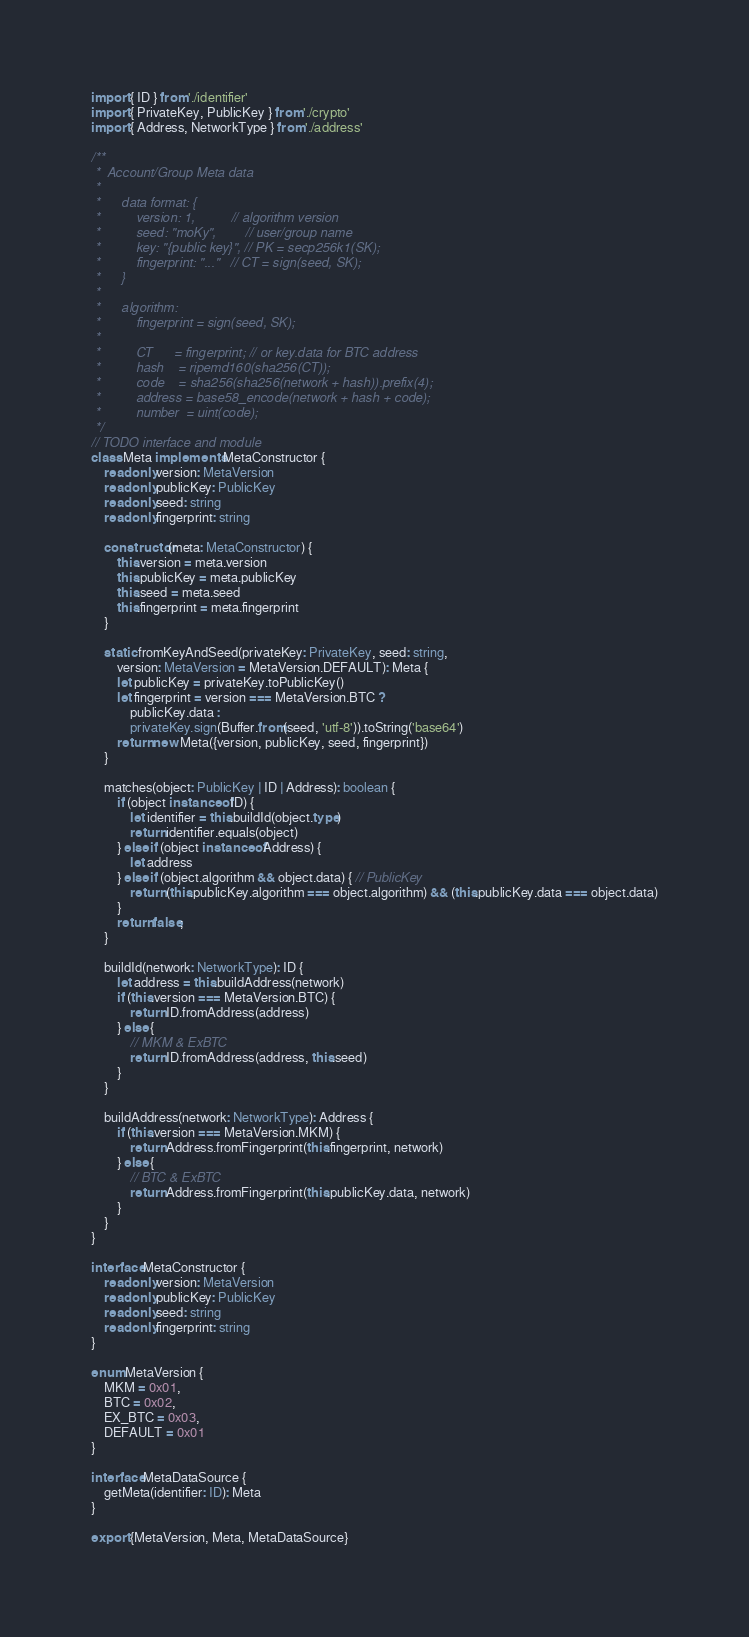<code> <loc_0><loc_0><loc_500><loc_500><_TypeScript_>import { ID } from './identifier'
import { PrivateKey, PublicKey } from './crypto'
import { Address, NetworkType } from './address'

/**
 *  Account/Group Meta data
 *
 *      data format: {
 *          version: 1,          // algorithm version
 *          seed: "moKy",        // user/group name
 *          key: "{public key}", // PK = secp256k1(SK);
 *          fingerprint: "..."   // CT = sign(seed, SK);
 *      }
 *
 *      algorithm:
 *          fingerprint = sign(seed, SK);
 *
 *          CT      = fingerprint; // or key.data for BTC address
 *          hash    = ripemd160(sha256(CT));
 *          code    = sha256(sha256(network + hash)).prefix(4);
 *          address = base58_encode(network + hash + code);
 *          number  = uint(code);
 */
// TODO interface and module
class Meta implements MetaConstructor {
    readonly version: MetaVersion
    readonly publicKey: PublicKey
    readonly seed: string
    readonly fingerprint: string

    constructor(meta: MetaConstructor) {
        this.version = meta.version
        this.publicKey = meta.publicKey
        this.seed = meta.seed
        this.fingerprint = meta.fingerprint
    }

    static fromKeyAndSeed(privateKey: PrivateKey, seed: string,
        version: MetaVersion = MetaVersion.DEFAULT): Meta {
        let publicKey = privateKey.toPublicKey()
        let fingerprint = version === MetaVersion.BTC ?
            publicKey.data :
            privateKey.sign(Buffer.from(seed, 'utf-8')).toString('base64')
        return new Meta({version, publicKey, seed, fingerprint})
    }
    
    matches(object: PublicKey | ID | Address): boolean {
        if (object instanceof ID) {
            let identifier = this.buildId(object.type)
            return identifier.equals(object)
        } else if (object instanceof Address) {
            let address
        } else if (object.algorithm && object.data) { // PublicKey
            return (this.publicKey.algorithm === object.algorithm) && (this.publicKey.data === object.data)
        }
        return false;
    }

    buildId(network: NetworkType): ID {
        let address = this.buildAddress(network)
        if (this.version === MetaVersion.BTC) {
            return ID.fromAddress(address)
        } else {
            // MKM & ExBTC
            return ID.fromAddress(address, this.seed)
        }
    }

    buildAddress(network: NetworkType): Address {
        if (this.version === MetaVersion.MKM) {
            return Address.fromFingerprint(this.fingerprint, network)
        } else {
            // BTC & ExBTC
            return Address.fromFingerprint(this.publicKey.data, network)
        }
    }
}

interface MetaConstructor {
    readonly version: MetaVersion
    readonly publicKey: PublicKey
    readonly seed: string
    readonly fingerprint: string
}

enum MetaVersion {
    MKM = 0x01,
    BTC = 0x02,
    EX_BTC = 0x03,
    DEFAULT = 0x01
}

interface MetaDataSource {
    getMeta(identifier: ID): Meta
}

export {MetaVersion, Meta, MetaDataSource}</code> 